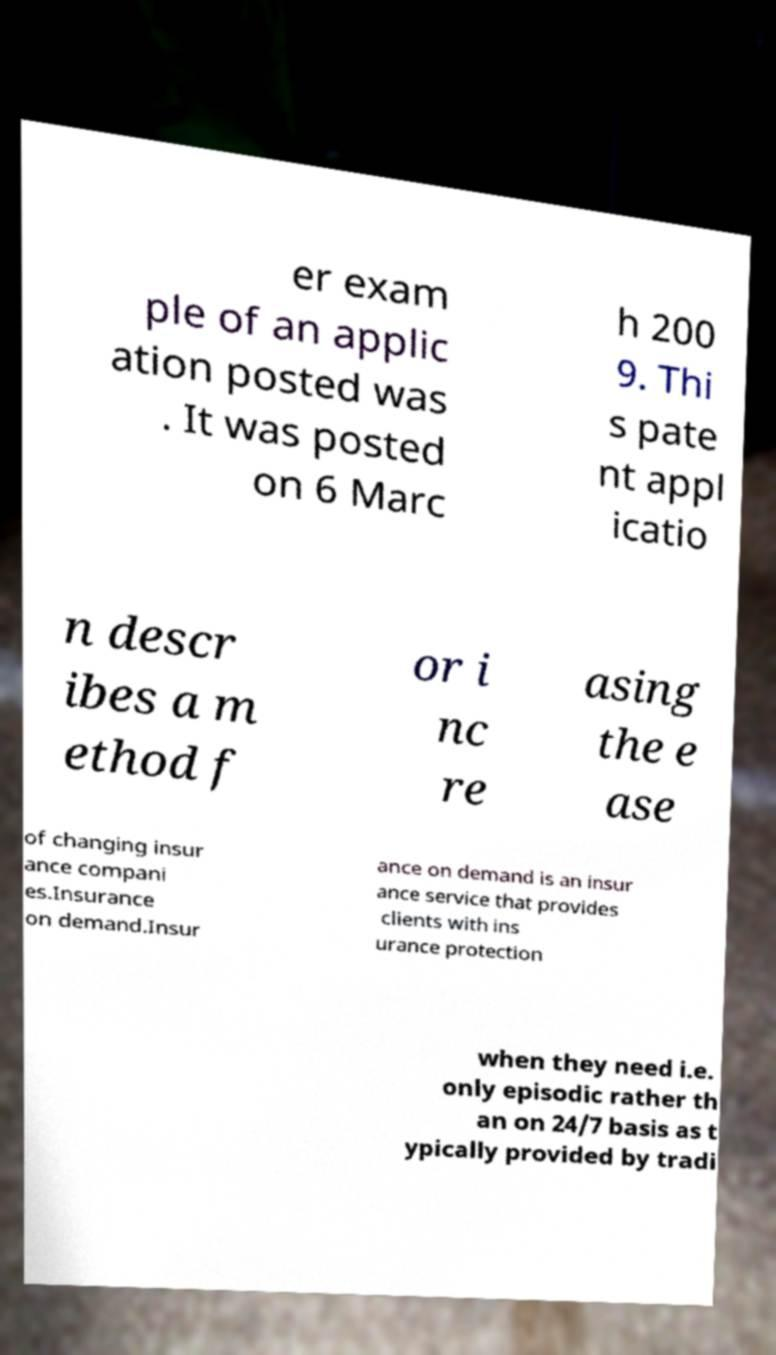For documentation purposes, I need the text within this image transcribed. Could you provide that? er exam ple of an applic ation posted was . It was posted on 6 Marc h 200 9. Thi s pate nt appl icatio n descr ibes a m ethod f or i nc re asing the e ase of changing insur ance compani es.Insurance on demand.Insur ance on demand is an insur ance service that provides clients with ins urance protection when they need i.e. only episodic rather th an on 24/7 basis as t ypically provided by tradi 